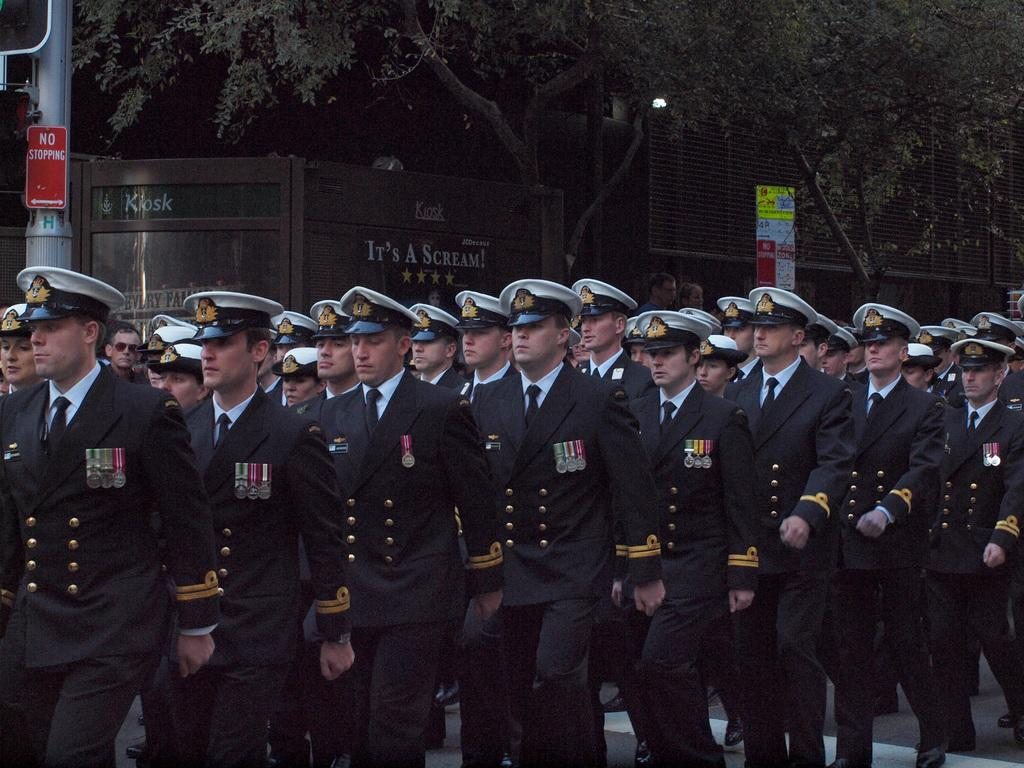What is the main subject of the image? The main subject of the image is a crowd. What are the people in the crowd wearing? The people in the crowd are wearing clothes and caps. What can be seen in the top part of the image? There is a tree and a pole in the top part of the image. Can you hear a yak coughing in the image? There is no yak or any sound in the image, as it is a still photograph. 